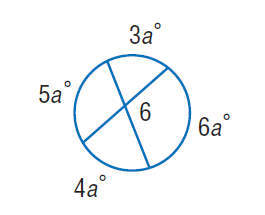Question: Find \angle 6.
Choices:
A. 110
B. 140
C. 150
D. 220
Answer with the letter. Answer: A 